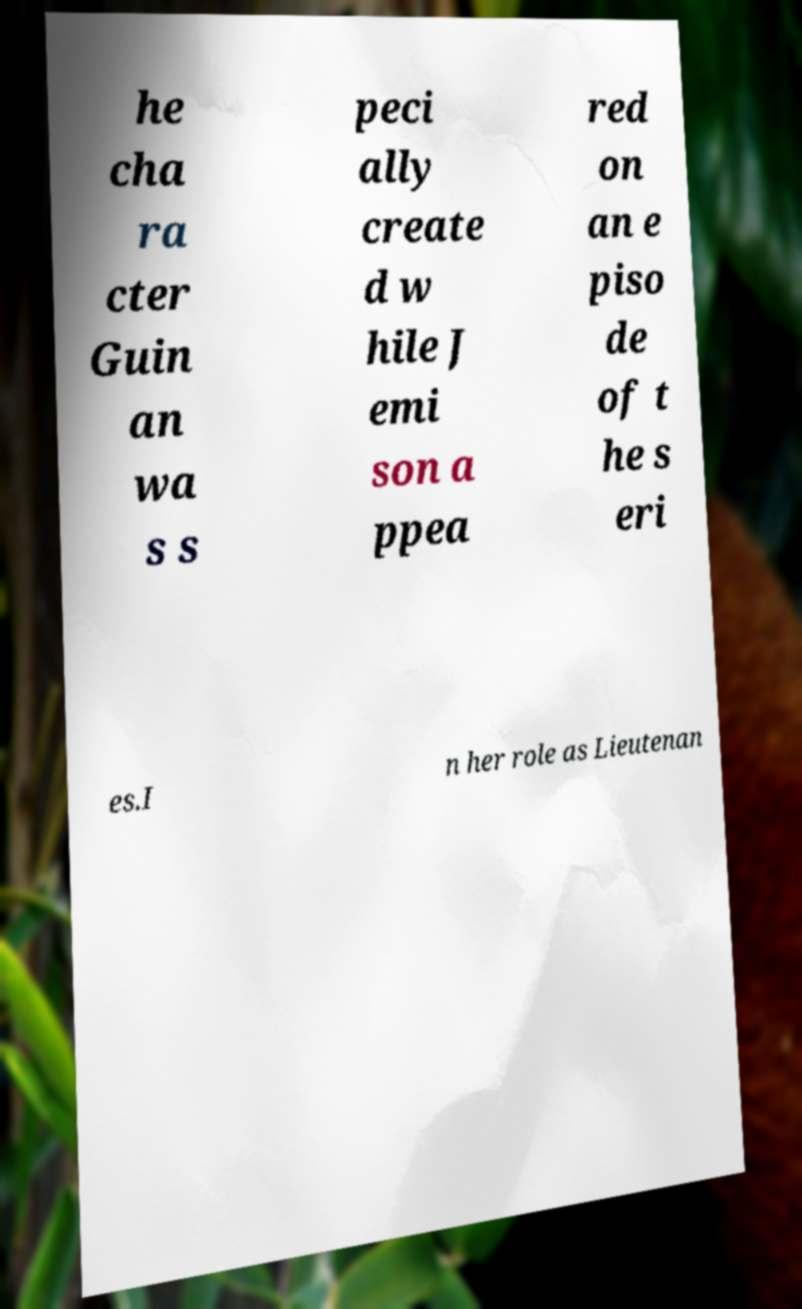What messages or text are displayed in this image? I need them in a readable, typed format. he cha ra cter Guin an wa s s peci ally create d w hile J emi son a ppea red on an e piso de of t he s eri es.I n her role as Lieutenan 